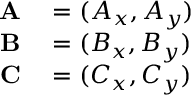<formula> <loc_0><loc_0><loc_500><loc_500>\begin{array} { r l } { A } & = ( A _ { x } , A _ { y } ) } \\ { B } & = ( B _ { x } , B _ { y } ) } \\ { C } & = ( C _ { x } , C _ { y } ) } \end{array}</formula> 